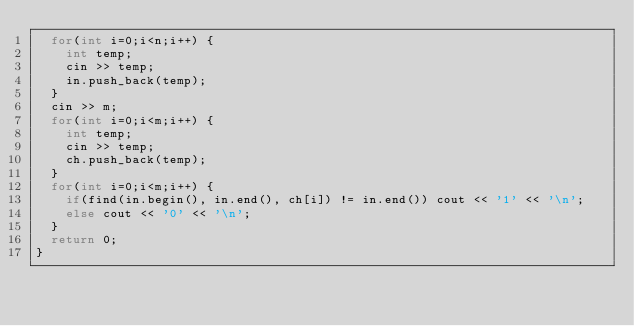Convert code to text. <code><loc_0><loc_0><loc_500><loc_500><_C++_>	for(int i=0;i<n;i++) {
		int temp;
		cin >> temp;
		in.push_back(temp);
	}
	cin >> m;
	for(int i=0;i<m;i++) {
		int temp;
		cin >> temp;
		ch.push_back(temp);
	}
	for(int i=0;i<m;i++) {
		if(find(in.begin(), in.end(), ch[i]) != in.end()) cout << '1' << '\n';
		else cout << '0' << '\n';
	}
	return 0;
}
</code> 